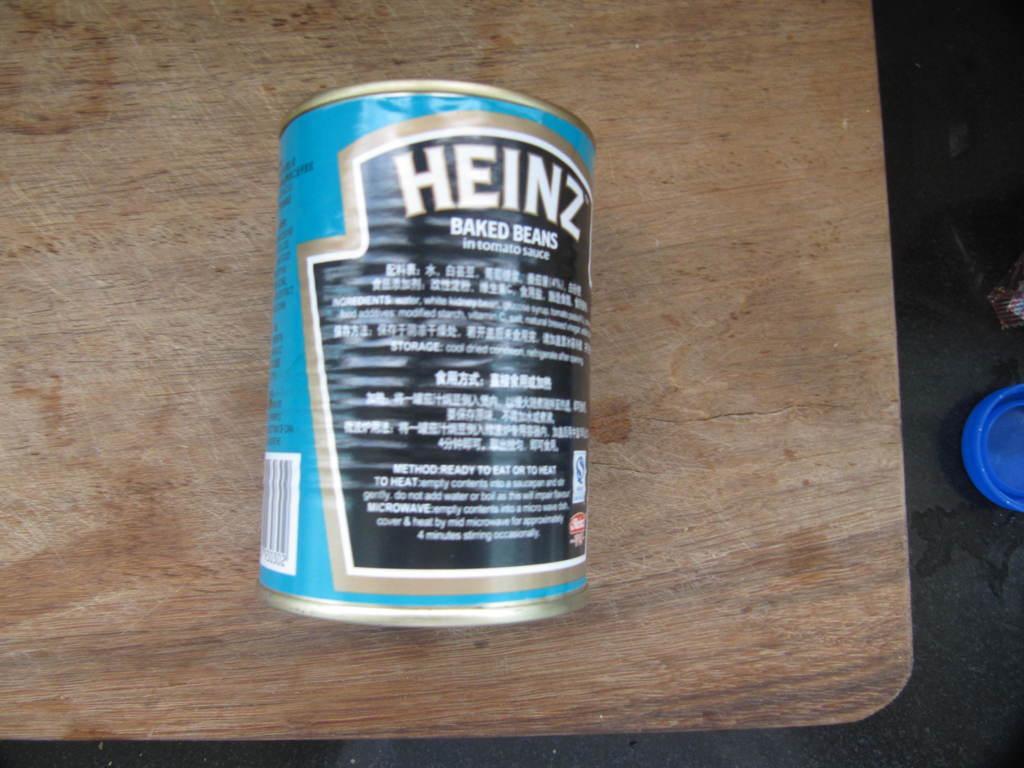How would you summarize this image in a sentence or two? In this image we can see a food can placed on the wooden surface. 